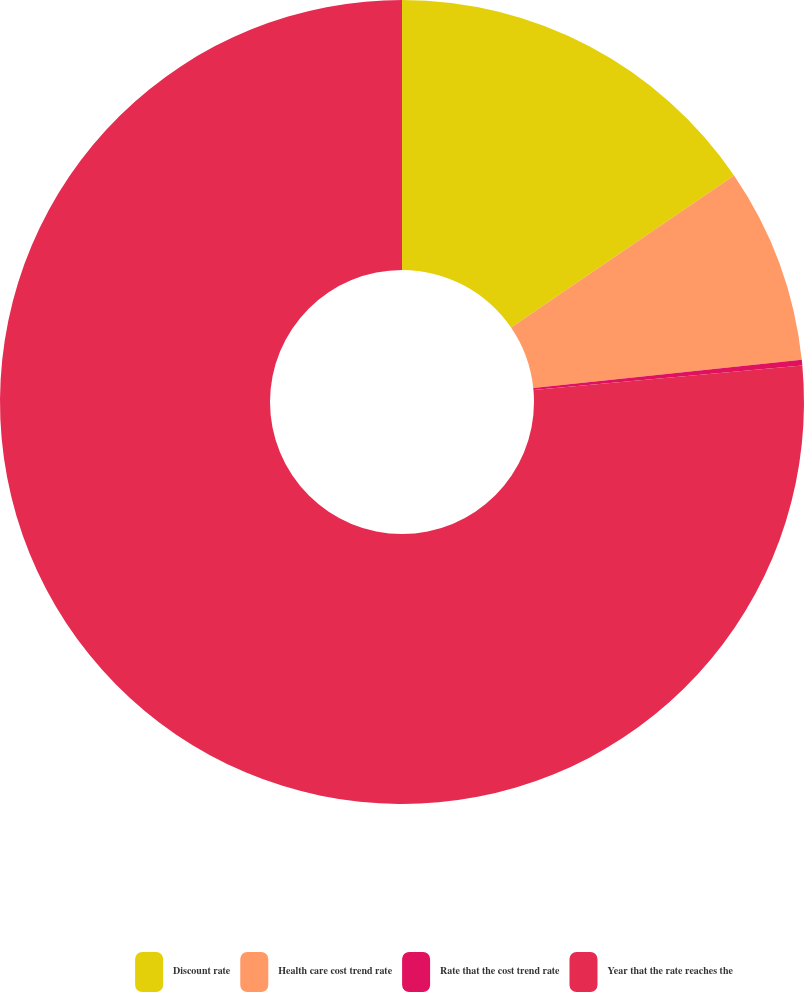Convert chart. <chart><loc_0><loc_0><loc_500><loc_500><pie_chart><fcel>Discount rate<fcel>Health care cost trend rate<fcel>Rate that the cost trend rate<fcel>Year that the rate reaches the<nl><fcel>15.47%<fcel>7.85%<fcel>0.23%<fcel>76.44%<nl></chart> 